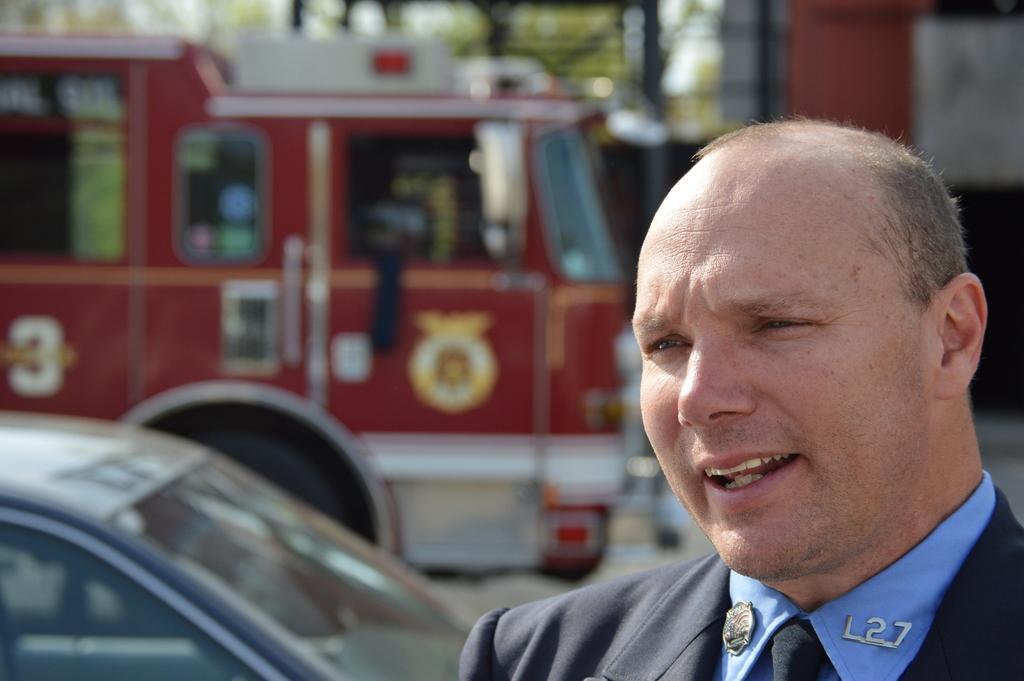Describe this image in one or two sentences. In this image we can see a person standing wears a blue shirt, there are two vehicles on the road and background it is blurry. 